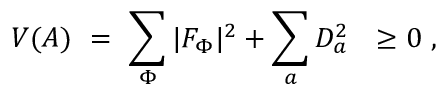Convert formula to latex. <formula><loc_0><loc_0><loc_500><loc_500>V ( A ) = \sum _ { \Phi } | F _ { \Phi } | ^ { 2 } + \sum _ { a } D _ { a } ^ { 2 } \geq 0 \ ,</formula> 